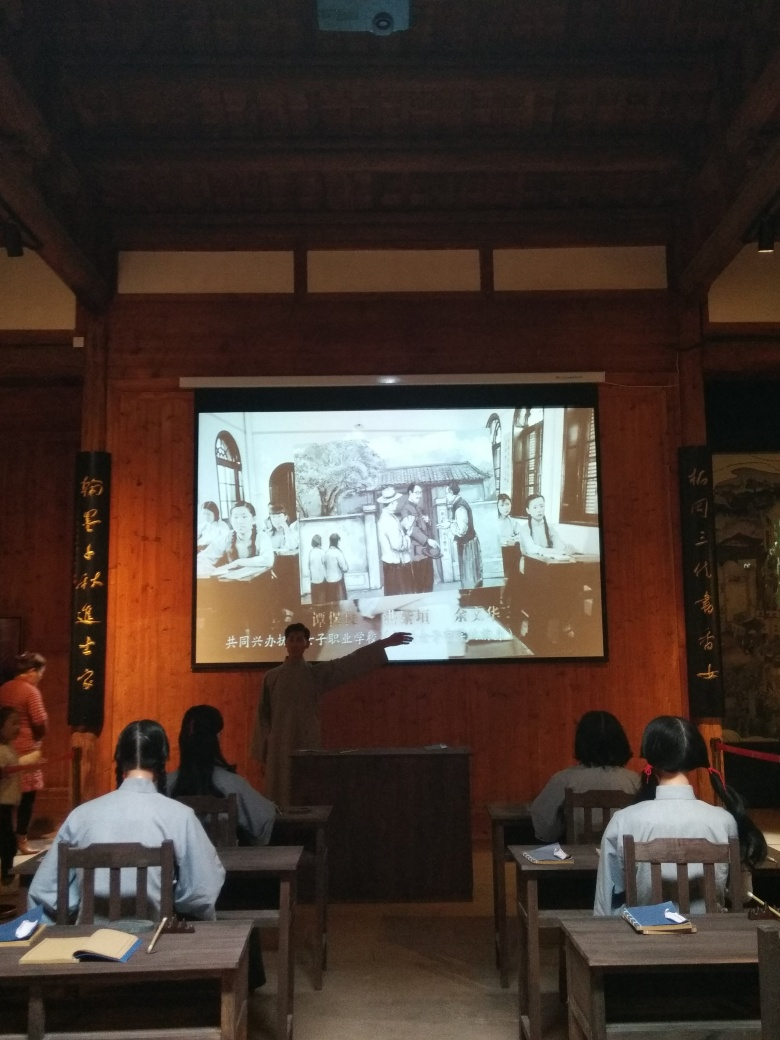Does the dark image result in the loss of some texture details? Indeed, the darker areas within the image can obscure finer textures and details, particularly in zones where shadow is prevalent. This is observable in the lower contrast sections where distinguishing individual elements becomes more challenging, affecting both the texture and depth perception of the objects or surfaces in question. 